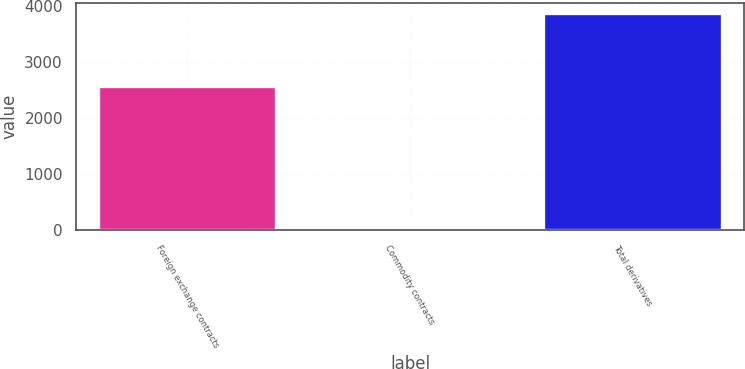Convert chart. <chart><loc_0><loc_0><loc_500><loc_500><bar_chart><fcel>Foreign exchange contracts<fcel>Commodity contracts<fcel>Total derivatives<nl><fcel>2584<fcel>53<fcel>3875<nl></chart> 